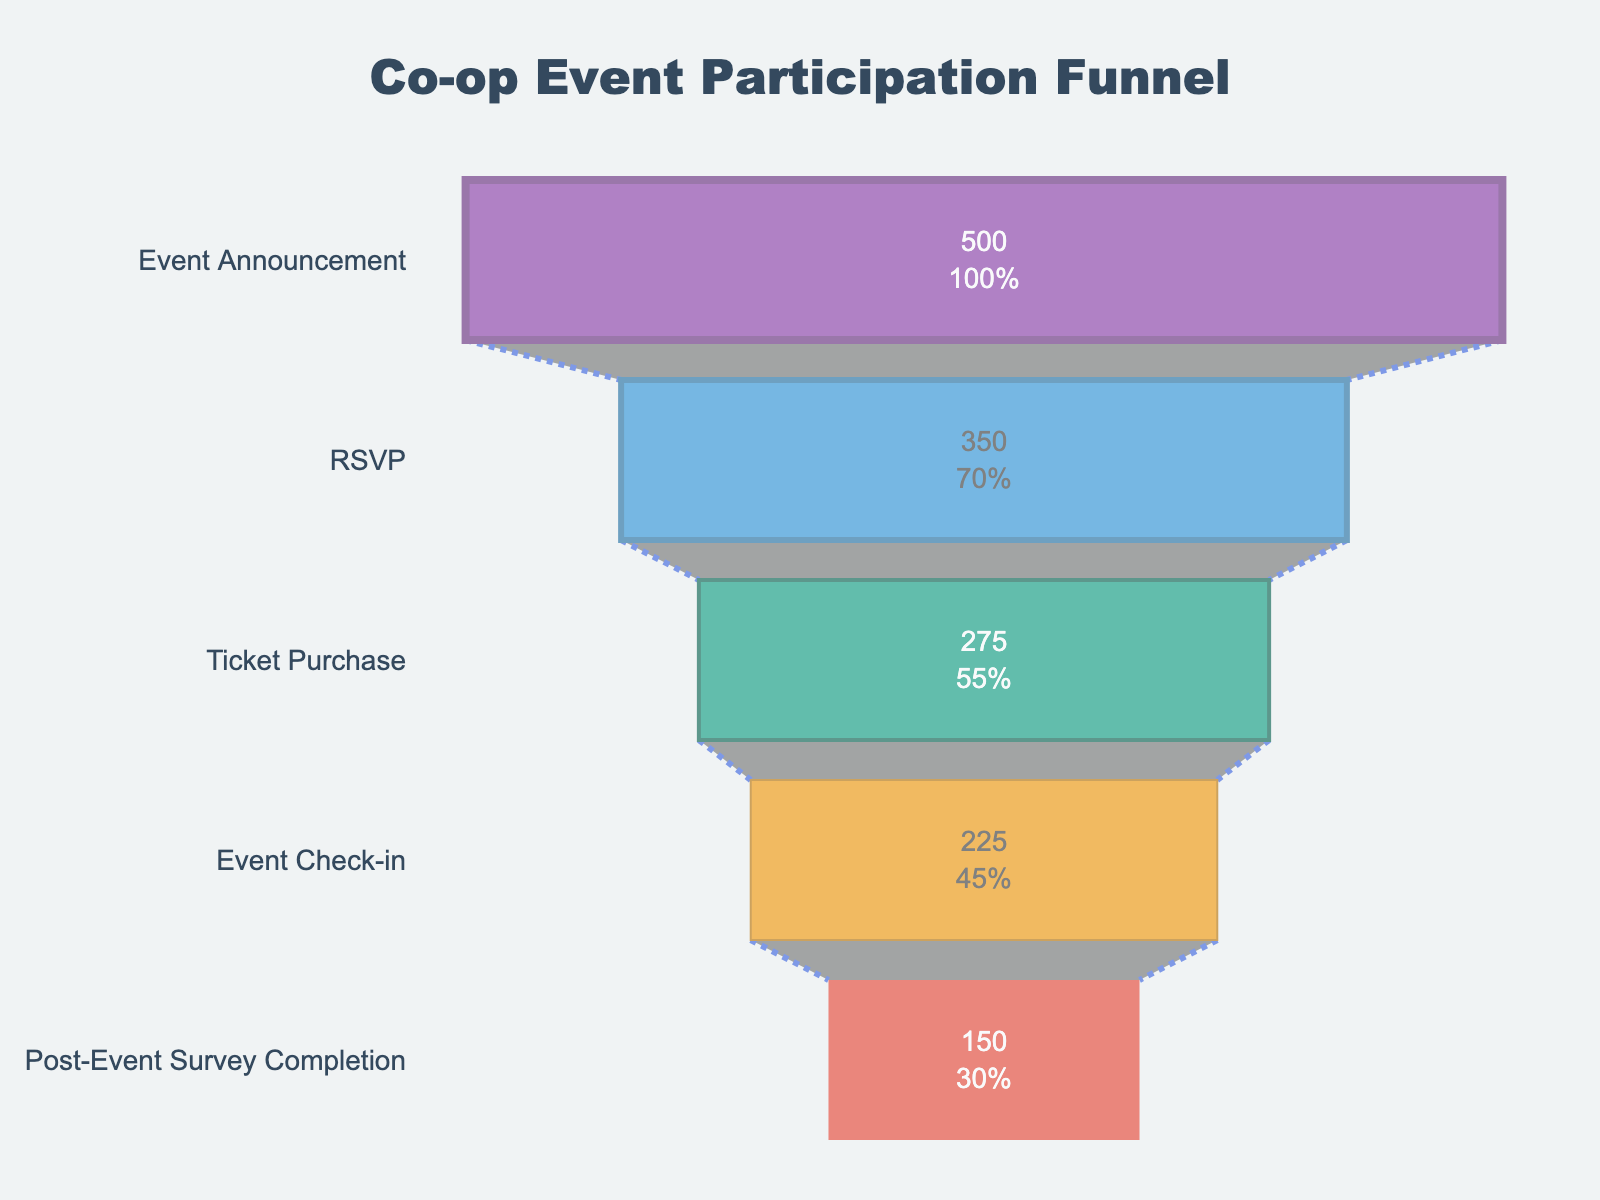What is the title of the funnel chart? The title is displayed prominently at the top of the chart. By reading it, we can identify the purpose of the chart.
Answer: Co-op Event Participation Funnel How many members RSVP'd for the event? The "RSVP" stage clearly shows the number of members who RSVP'd, written inside the funnel section.
Answer: 350 What percentage of members who received the event announcement ended up purchasing tickets? First, locate the "Event Announcement" stage and note its value (500). Then, find the "Ticket Purchase" stage and note its value (275). The percentage is calculated as (275 / 500) * 100.
Answer: 55% Compare the number of members who checked in to the event with those who completed the post-event survey. Which stage had fewer members? Locate the "Event Check-in" and "Post-Event Survey Completion" stages. Compare the values of each: 225 (Check-in) vs. 150 (Survey Completion).
Answer: Post-Event Survey Completion What is the color of the "Ticket Purchase" stage in the funnel? Identify and describe the specific color used for the "Ticket Purchase" section in the chart, located third from the top.
Answer: #16A085 (a shade of green) By how much did the number of members decrease from the RSVP stage to the Event Check-in stage? Subtract the value at the "Event Check-in" stage from the value at the "RSVP" stage: 350 - 225.
Answer: 125 What is the final stage in the funnel chart, and how many members reached this stage? Identify the last stage listed in the funnel and the number of members represented in this stage, found at the bottom of the chart.
Answer: Post-Event Survey Completion, 150 What percentage of members who purchased tickets attended the event? First, locate the "Ticket Purchase" stage and note its value (275). Then, find the "Event Check-in" stage and note its value (225). The percentage is calculated as (225 / 275) * 100.
Answer: 81.82% Which stage of the funnel saw the largest drop-off in member numbers? Calculate the differences between consecutive stages to identify the largest drop-off: (500 - 350 = 150), (350 - 275 = 75), (275 - 225 = 50), (225 - 150 = 75).
Answer: Event Announcement to RSVP How many stages are there in the funnel chart? Count the unique stages listed on the y-axis of the funnel chart.
Answer: 5 